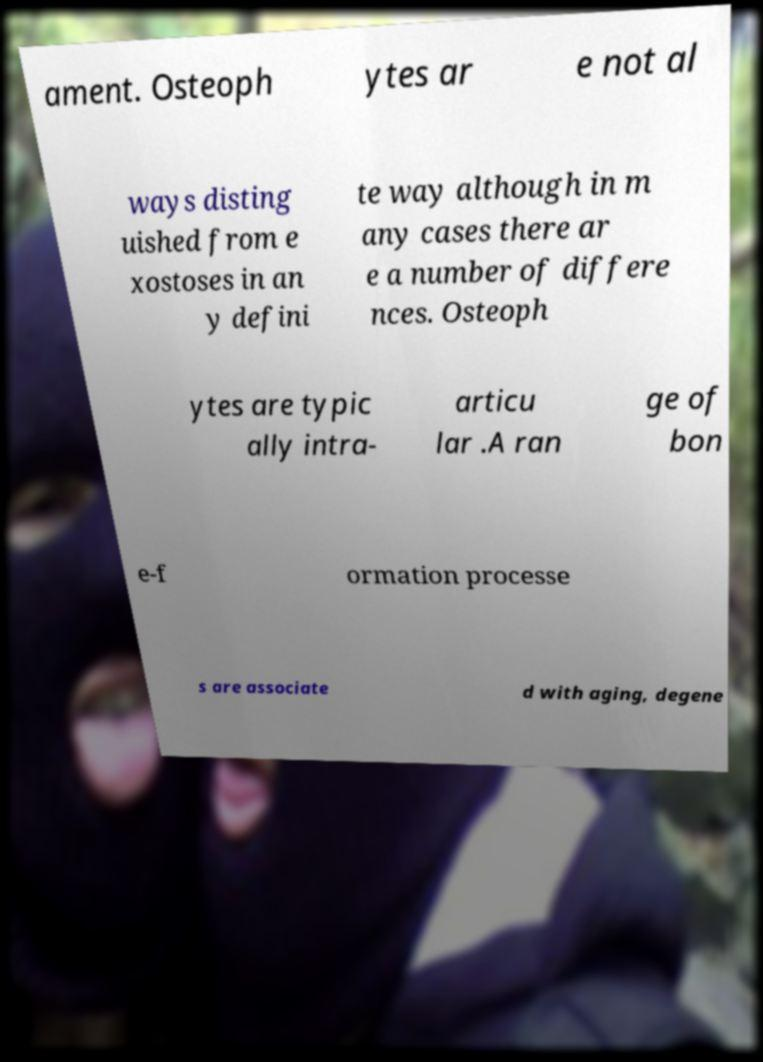Could you assist in decoding the text presented in this image and type it out clearly? ament. Osteoph ytes ar e not al ways disting uished from e xostoses in an y defini te way although in m any cases there ar e a number of differe nces. Osteoph ytes are typic ally intra- articu lar .A ran ge of bon e-f ormation processe s are associate d with aging, degene 